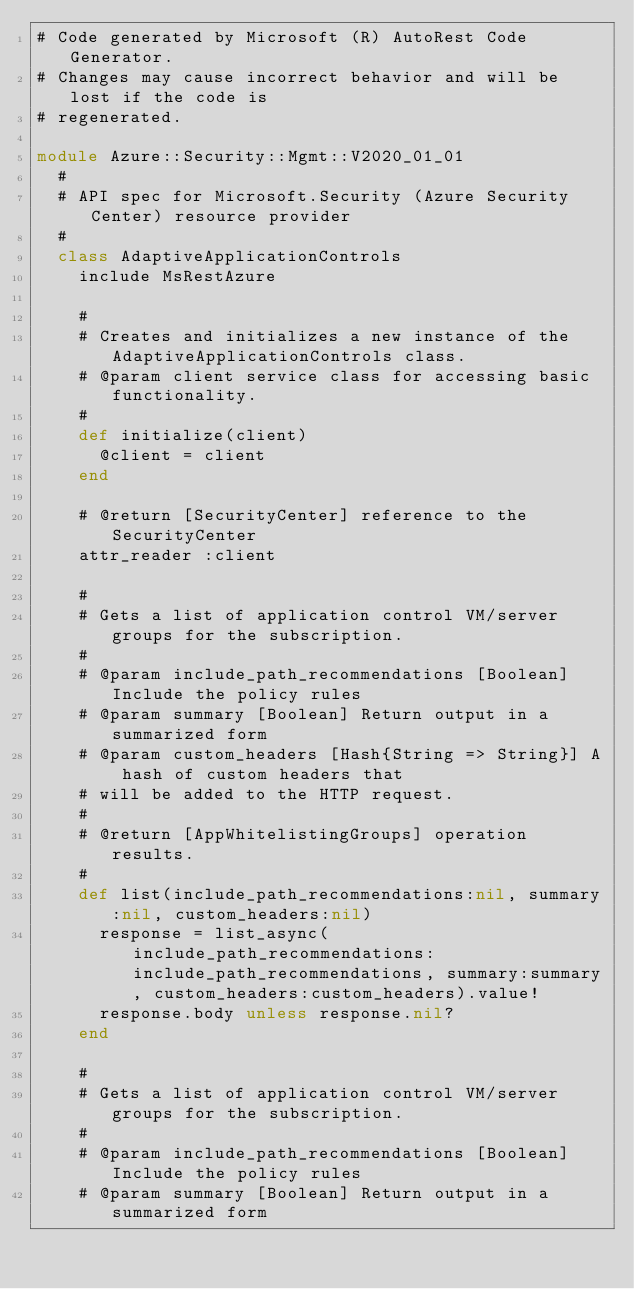<code> <loc_0><loc_0><loc_500><loc_500><_Ruby_># Code generated by Microsoft (R) AutoRest Code Generator.
# Changes may cause incorrect behavior and will be lost if the code is
# regenerated.

module Azure::Security::Mgmt::V2020_01_01
  #
  # API spec for Microsoft.Security (Azure Security Center) resource provider
  #
  class AdaptiveApplicationControls
    include MsRestAzure

    #
    # Creates and initializes a new instance of the AdaptiveApplicationControls class.
    # @param client service class for accessing basic functionality.
    #
    def initialize(client)
      @client = client
    end

    # @return [SecurityCenter] reference to the SecurityCenter
    attr_reader :client

    #
    # Gets a list of application control VM/server groups for the subscription.
    #
    # @param include_path_recommendations [Boolean] Include the policy rules
    # @param summary [Boolean] Return output in a summarized form
    # @param custom_headers [Hash{String => String}] A hash of custom headers that
    # will be added to the HTTP request.
    #
    # @return [AppWhitelistingGroups] operation results.
    #
    def list(include_path_recommendations:nil, summary:nil, custom_headers:nil)
      response = list_async(include_path_recommendations:include_path_recommendations, summary:summary, custom_headers:custom_headers).value!
      response.body unless response.nil?
    end

    #
    # Gets a list of application control VM/server groups for the subscription.
    #
    # @param include_path_recommendations [Boolean] Include the policy rules
    # @param summary [Boolean] Return output in a summarized form</code> 